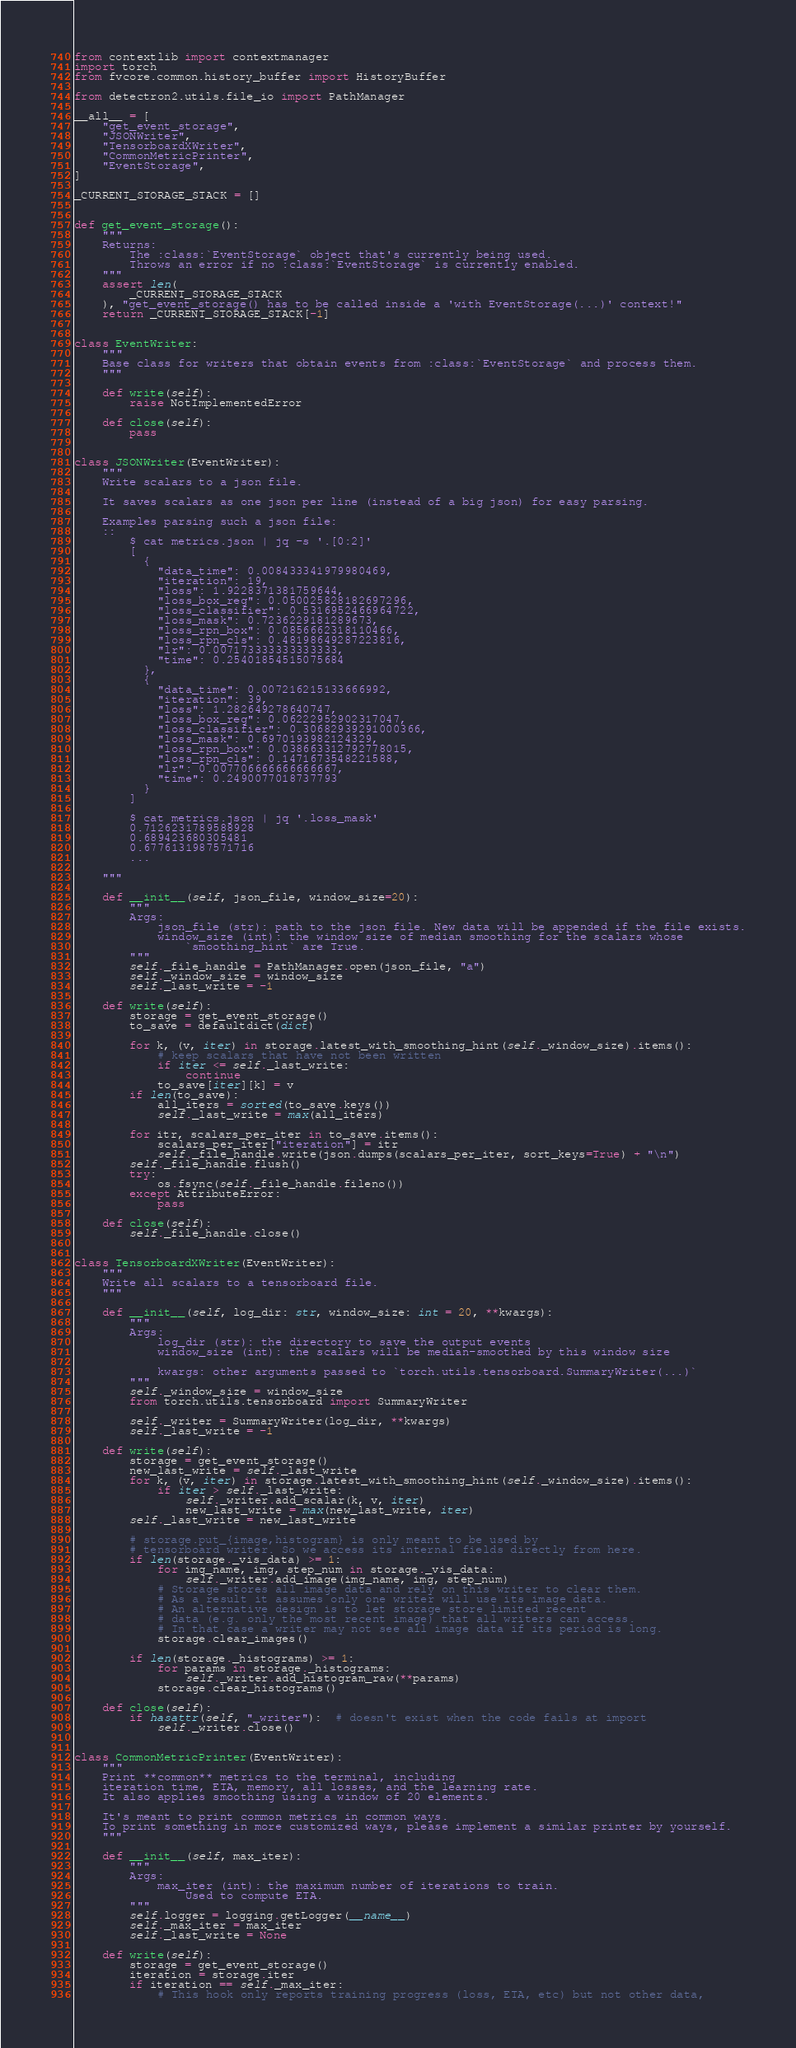<code> <loc_0><loc_0><loc_500><loc_500><_Python_>from contextlib import contextmanager
import torch
from fvcore.common.history_buffer import HistoryBuffer

from detectron2.utils.file_io import PathManager

__all__ = [
    "get_event_storage",
    "JSONWriter",
    "TensorboardXWriter",
    "CommonMetricPrinter",
    "EventStorage",
]

_CURRENT_STORAGE_STACK = []


def get_event_storage():
    """
    Returns:
        The :class:`EventStorage` object that's currently being used.
        Throws an error if no :class:`EventStorage` is currently enabled.
    """
    assert len(
        _CURRENT_STORAGE_STACK
    ), "get_event_storage() has to be called inside a 'with EventStorage(...)' context!"
    return _CURRENT_STORAGE_STACK[-1]


class EventWriter:
    """
    Base class for writers that obtain events from :class:`EventStorage` and process them.
    """

    def write(self):
        raise NotImplementedError

    def close(self):
        pass


class JSONWriter(EventWriter):
    """
    Write scalars to a json file.

    It saves scalars as one json per line (instead of a big json) for easy parsing.

    Examples parsing such a json file:
    ::
        $ cat metrics.json | jq -s '.[0:2]'
        [
          {
            "data_time": 0.008433341979980469,
            "iteration": 19,
            "loss": 1.9228371381759644,
            "loss_box_reg": 0.050025828182697296,
            "loss_classifier": 0.5316952466964722,
            "loss_mask": 0.7236229181289673,
            "loss_rpn_box": 0.0856662318110466,
            "loss_rpn_cls": 0.48198649287223816,
            "lr": 0.007173333333333333,
            "time": 0.25401854515075684
          },
          {
            "data_time": 0.007216215133666992,
            "iteration": 39,
            "loss": 1.282649278640747,
            "loss_box_reg": 0.06222952902317047,
            "loss_classifier": 0.30682939291000366,
            "loss_mask": 0.6970193982124329,
            "loss_rpn_box": 0.038663312792778015,
            "loss_rpn_cls": 0.1471673548221588,
            "lr": 0.007706666666666667,
            "time": 0.2490077018737793
          }
        ]

        $ cat metrics.json | jq '.loss_mask'
        0.7126231789588928
        0.689423680305481
        0.6776131987571716
        ...

    """

    def __init__(self, json_file, window_size=20):
        """
        Args:
            json_file (str): path to the json file. New data will be appended if the file exists.
            window_size (int): the window size of median smoothing for the scalars whose
                `smoothing_hint` are True.
        """
        self._file_handle = PathManager.open(json_file, "a")
        self._window_size = window_size
        self._last_write = -1

    def write(self):
        storage = get_event_storage()
        to_save = defaultdict(dict)

        for k, (v, iter) in storage.latest_with_smoothing_hint(self._window_size).items():
            # keep scalars that have not been written
            if iter <= self._last_write:
                continue
            to_save[iter][k] = v
        if len(to_save):
            all_iters = sorted(to_save.keys())
            self._last_write = max(all_iters)

        for itr, scalars_per_iter in to_save.items():
            scalars_per_iter["iteration"] = itr
            self._file_handle.write(json.dumps(scalars_per_iter, sort_keys=True) + "\n")
        self._file_handle.flush()
        try:
            os.fsync(self._file_handle.fileno())
        except AttributeError:
            pass

    def close(self):
        self._file_handle.close()


class TensorboardXWriter(EventWriter):
    """
    Write all scalars to a tensorboard file.
    """

    def __init__(self, log_dir: str, window_size: int = 20, **kwargs):
        """
        Args:
            log_dir (str): the directory to save the output events
            window_size (int): the scalars will be median-smoothed by this window size

            kwargs: other arguments passed to `torch.utils.tensorboard.SummaryWriter(...)`
        """
        self._window_size = window_size
        from torch.utils.tensorboard import SummaryWriter

        self._writer = SummaryWriter(log_dir, **kwargs)
        self._last_write = -1

    def write(self):
        storage = get_event_storage()
        new_last_write = self._last_write
        for k, (v, iter) in storage.latest_with_smoothing_hint(self._window_size).items():
            if iter > self._last_write:
                self._writer.add_scalar(k, v, iter)
                new_last_write = max(new_last_write, iter)
        self._last_write = new_last_write

        # storage.put_{image,histogram} is only meant to be used by
        # tensorboard writer. So we access its internal fields directly from here.
        if len(storage._vis_data) >= 1:
            for img_name, img, step_num in storage._vis_data:
                self._writer.add_image(img_name, img, step_num)
            # Storage stores all image data and rely on this writer to clear them.
            # As a result it assumes only one writer will use its image data.
            # An alternative design is to let storage store limited recent
            # data (e.g. only the most recent image) that all writers can access.
            # In that case a writer may not see all image data if its period is long.
            storage.clear_images()

        if len(storage._histograms) >= 1:
            for params in storage._histograms:
                self._writer.add_histogram_raw(**params)
            storage.clear_histograms()

    def close(self):
        if hasattr(self, "_writer"):  # doesn't exist when the code fails at import
            self._writer.close()


class CommonMetricPrinter(EventWriter):
    """
    Print **common** metrics to the terminal, including
    iteration time, ETA, memory, all losses, and the learning rate.
    It also applies smoothing using a window of 20 elements.

    It's meant to print common metrics in common ways.
    To print something in more customized ways, please implement a similar printer by yourself.
    """

    def __init__(self, max_iter):
        """
        Args:
            max_iter (int): the maximum number of iterations to train.
                Used to compute ETA.
        """
        self.logger = logging.getLogger(__name__)
        self._max_iter = max_iter
        self._last_write = None

    def write(self):
        storage = get_event_storage()
        iteration = storage.iter
        if iteration == self._max_iter:
            # This hook only reports training progress (loss, ETA, etc) but not other data,</code> 